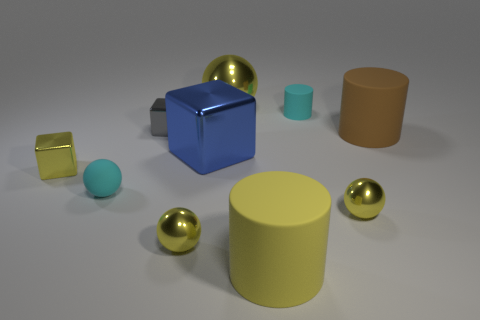How many big objects are metal blocks or rubber cylinders?
Offer a very short reply. 3. Is the shape of the big blue metallic object the same as the tiny gray metal thing?
Offer a very short reply. Yes. What number of cyan rubber objects are right of the big yellow matte thing and on the left side of the large yellow cylinder?
Offer a terse response. 0. Is there any other thing of the same color as the large sphere?
Your answer should be very brief. Yes. What is the shape of the big yellow thing that is the same material as the blue object?
Ensure brevity in your answer.  Sphere. Does the brown matte object have the same size as the rubber sphere?
Offer a very short reply. No. Are the tiny cube to the right of the tiny cyan matte ball and the large brown object made of the same material?
Your response must be concise. No. Are there any other things that have the same material as the large blue cube?
Keep it short and to the point. Yes. There is a tiny metallic sphere that is on the left side of the small shiny ball on the right side of the tiny rubber cylinder; how many tiny spheres are on the right side of it?
Offer a very short reply. 1. There is a yellow rubber thing that is on the right side of the large yellow shiny object; does it have the same shape as the gray metal thing?
Your answer should be compact. No. 